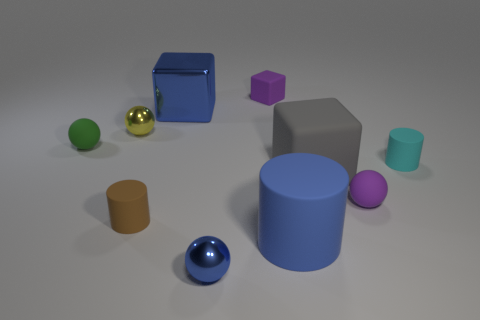What number of other things are the same color as the small block?
Your answer should be very brief. 1. There is a big cube behind the cyan matte cylinder; what is it made of?
Your answer should be compact. Metal. What is the large blue object behind the tiny cylinder on the left side of the small purple object that is to the left of the purple matte ball made of?
Your response must be concise. Metal. What number of small metallic balls are left of the purple rubber object right of the big cylinder?
Ensure brevity in your answer.  2. There is a small rubber thing that is the same shape as the big gray thing; what is its color?
Provide a succinct answer. Purple. Do the small green ball and the tiny purple ball have the same material?
Your answer should be compact. Yes. What number of cylinders are brown objects or green things?
Offer a terse response. 1. There is a yellow thing that is to the left of the tiny brown rubber cylinder that is in front of the purple thing that is behind the metal cube; what size is it?
Your response must be concise. Small. The other purple thing that is the same shape as the big metal thing is what size?
Give a very brief answer. Small. There is a yellow sphere; what number of spheres are left of it?
Make the answer very short. 1. 